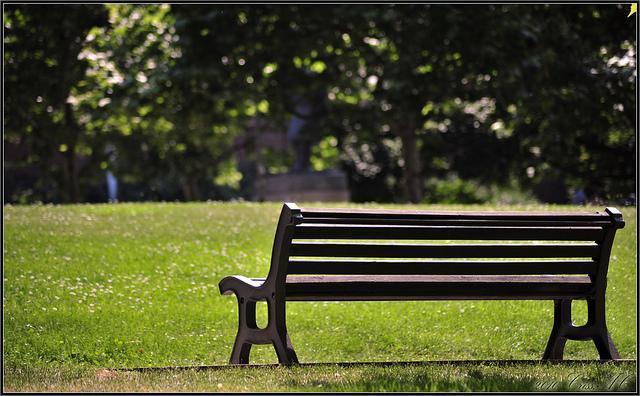How many park benches do you see?
Give a very brief answer. 1. How many people are wearing glasses in this image?
Give a very brief answer. 0. 